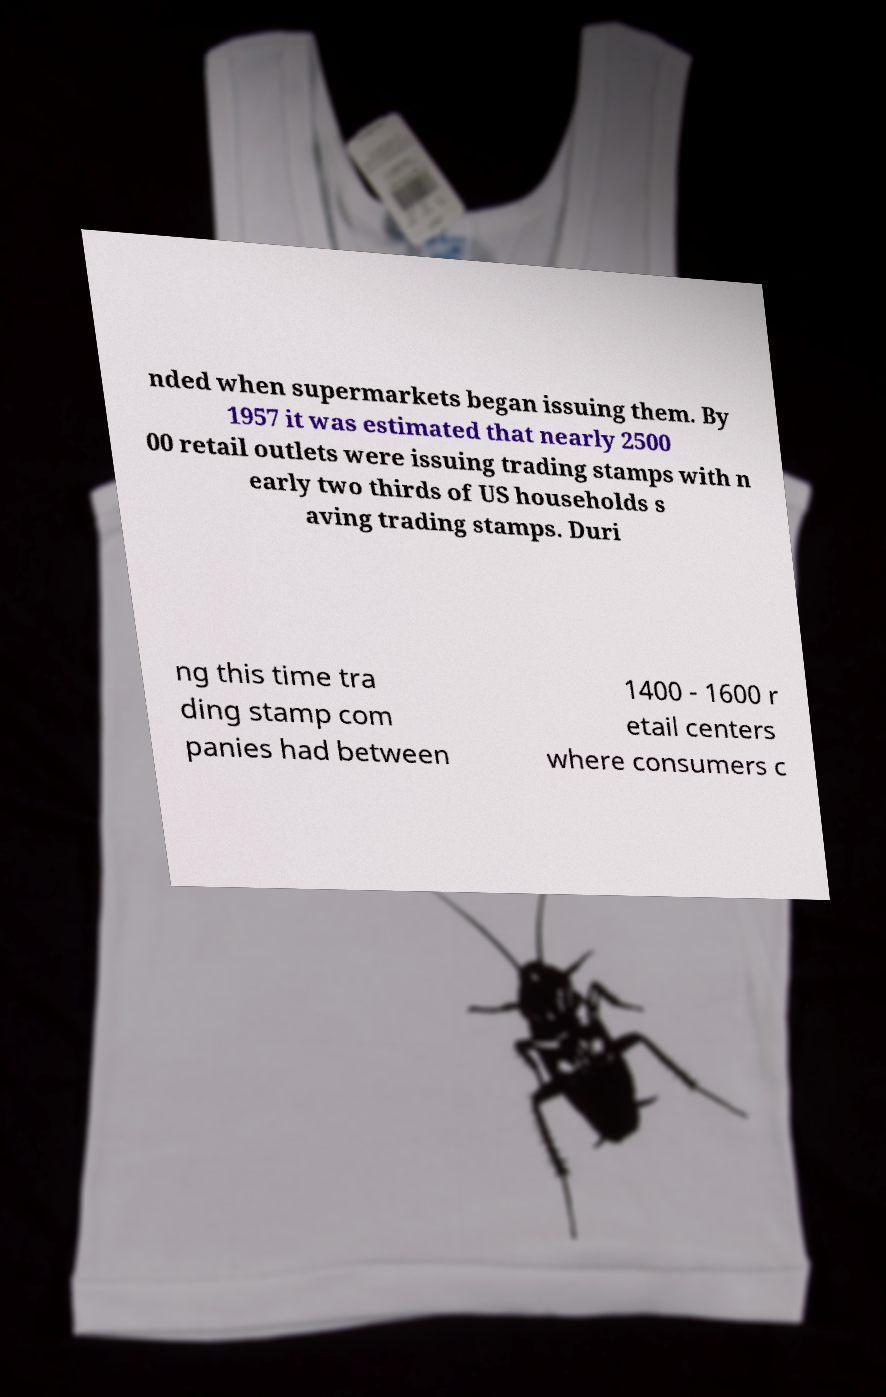Could you extract and type out the text from this image? nded when supermarkets began issuing them. By 1957 it was estimated that nearly 2500 00 retail outlets were issuing trading stamps with n early two thirds of US households s aving trading stamps. Duri ng this time tra ding stamp com panies had between 1400 - 1600 r etail centers where consumers c 